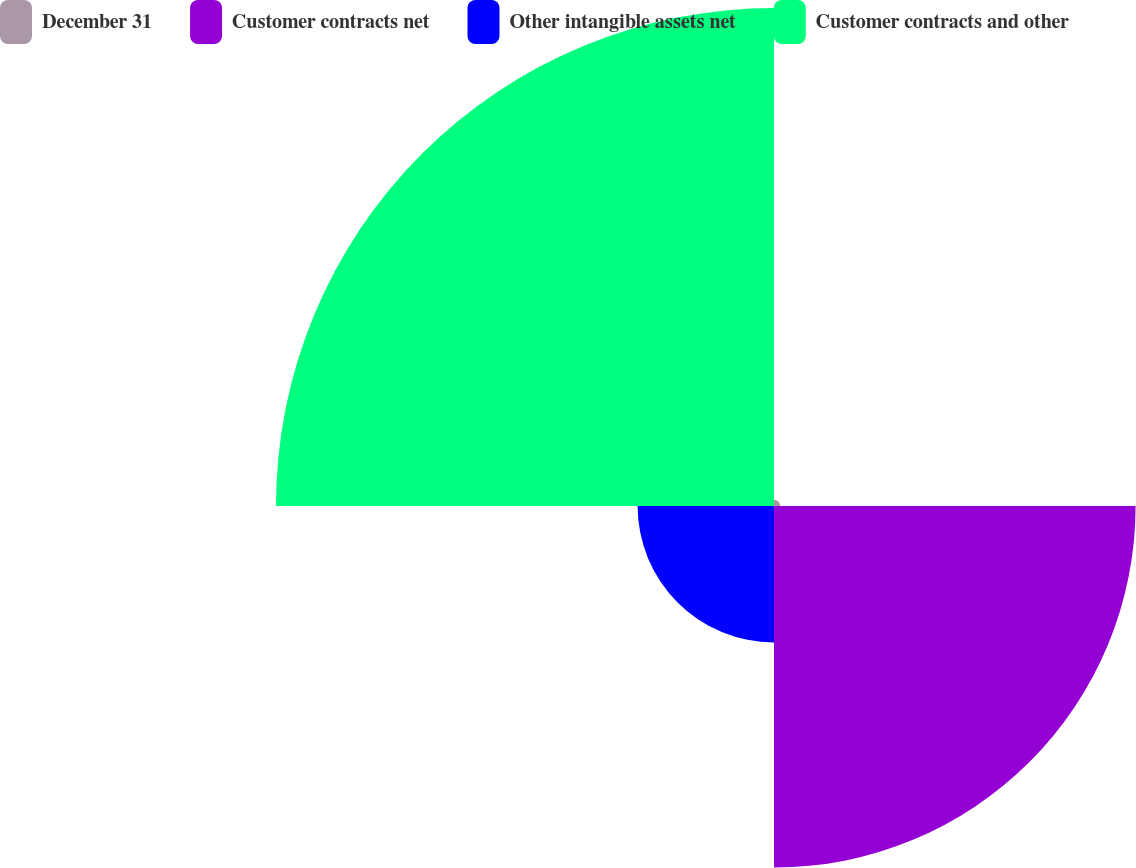<chart> <loc_0><loc_0><loc_500><loc_500><pie_chart><fcel>December 31<fcel>Customer contracts net<fcel>Other intangible assets net<fcel>Customer contracts and other<nl><fcel>0.62%<fcel>36.08%<fcel>13.61%<fcel>49.69%<nl></chart> 